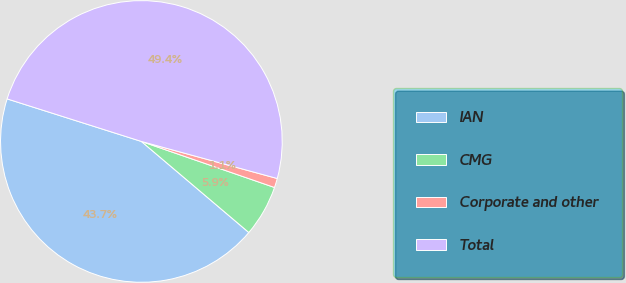Convert chart. <chart><loc_0><loc_0><loc_500><loc_500><pie_chart><fcel>IAN<fcel>CMG<fcel>Corporate and other<fcel>Total<nl><fcel>43.7%<fcel>5.89%<fcel>1.06%<fcel>49.36%<nl></chart> 